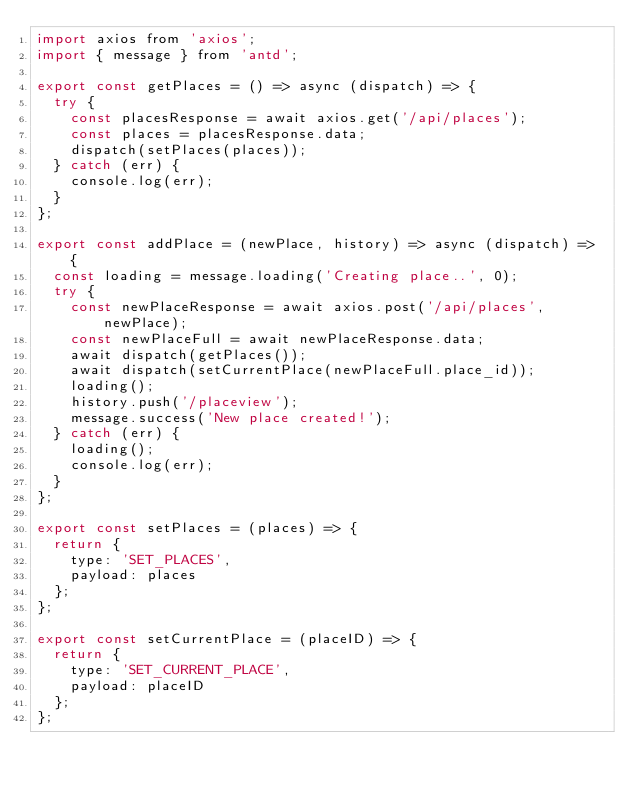Convert code to text. <code><loc_0><loc_0><loc_500><loc_500><_JavaScript_>import axios from 'axios';
import { message } from 'antd';

export const getPlaces = () => async (dispatch) => {
  try {
    const placesResponse = await axios.get('/api/places');
    const places = placesResponse.data;
    dispatch(setPlaces(places));
  } catch (err) {
    console.log(err);
  }
};

export const addPlace = (newPlace, history) => async (dispatch) => {
  const loading = message.loading('Creating place..', 0);
  try {
    const newPlaceResponse = await axios.post('/api/places', newPlace);
    const newPlaceFull = await newPlaceResponse.data;
    await dispatch(getPlaces());
    await dispatch(setCurrentPlace(newPlaceFull.place_id));
    loading();
    history.push('/placeview');
    message.success('New place created!');
  } catch (err) {
    loading();
    console.log(err);
  }
};

export const setPlaces = (places) => {
  return {
    type: 'SET_PLACES',
    payload: places
  };
};

export const setCurrentPlace = (placeID) => {
  return {
    type: 'SET_CURRENT_PLACE',
    payload: placeID
  };
};
</code> 